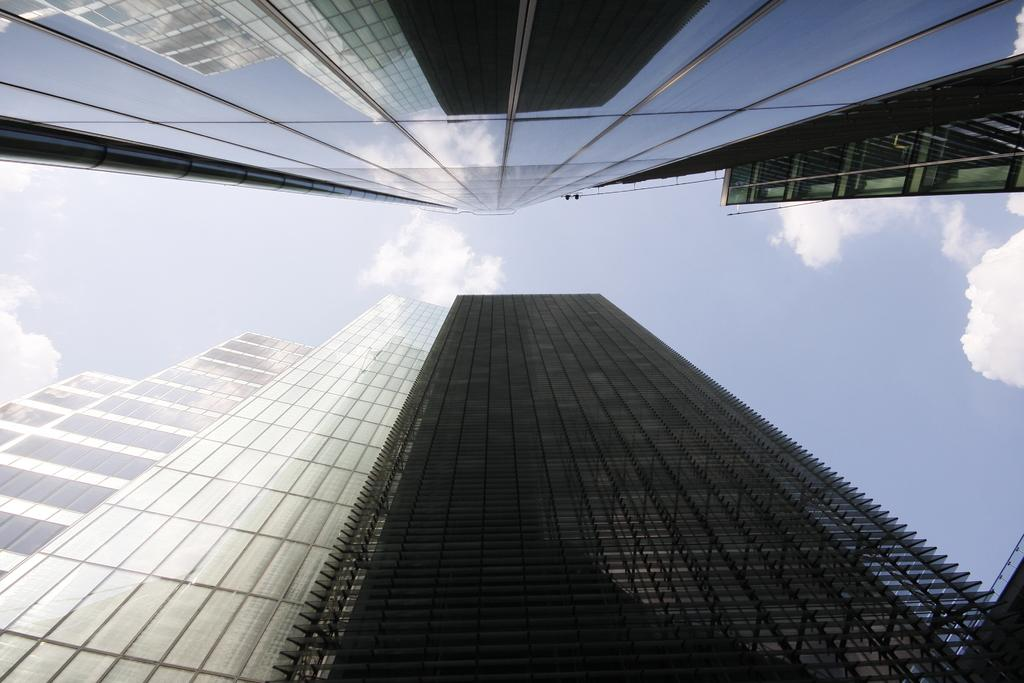What type of structures can be seen in the image? There are buildings in the image. What part of the natural environment is visible in the image? The sky is visible in the image. What can be observed in the sky? Clouds are present in the sky. What material is present in the image that has reflections? There is glass in the image that has reflections. What types of reflections can be seen on the glass? The glass has reflections of buildings and the sky. What does the son do after the aftermath of the hand in the image? There is no son, hand, or aftermath present in the image. 